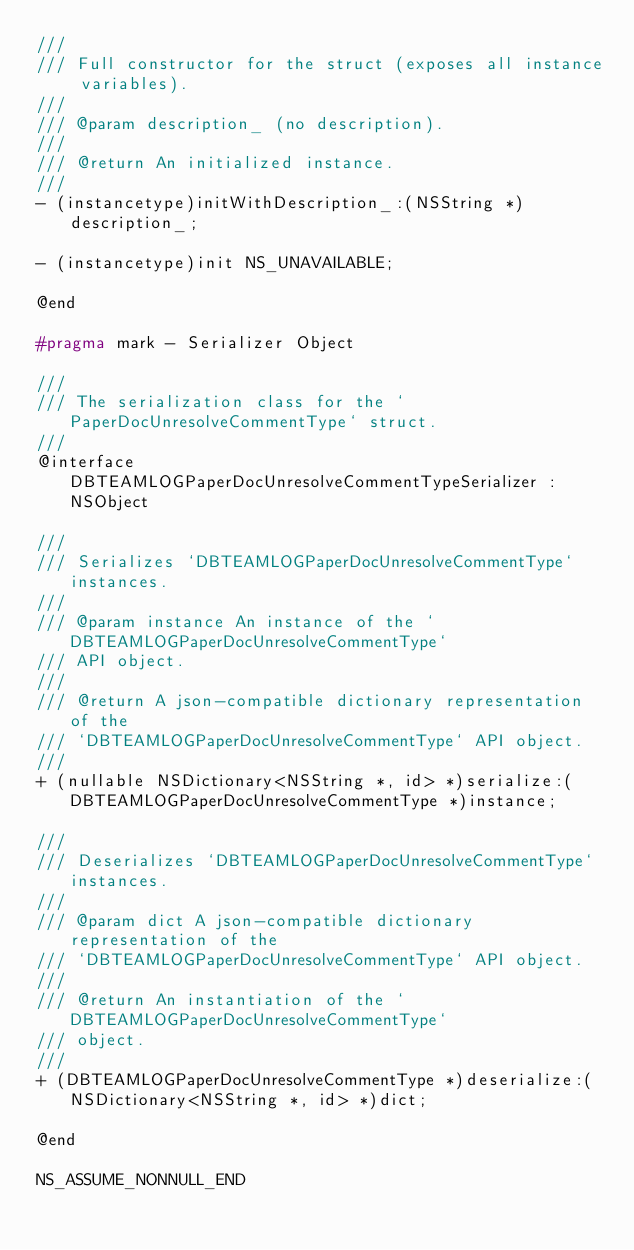Convert code to text. <code><loc_0><loc_0><loc_500><loc_500><_C_>///
/// Full constructor for the struct (exposes all instance variables).
///
/// @param description_ (no description).
///
/// @return An initialized instance.
///
- (instancetype)initWithDescription_:(NSString *)description_;

- (instancetype)init NS_UNAVAILABLE;

@end

#pragma mark - Serializer Object

///
/// The serialization class for the `PaperDocUnresolveCommentType` struct.
///
@interface DBTEAMLOGPaperDocUnresolveCommentTypeSerializer : NSObject

///
/// Serializes `DBTEAMLOGPaperDocUnresolveCommentType` instances.
///
/// @param instance An instance of the `DBTEAMLOGPaperDocUnresolveCommentType`
/// API object.
///
/// @return A json-compatible dictionary representation of the
/// `DBTEAMLOGPaperDocUnresolveCommentType` API object.
///
+ (nullable NSDictionary<NSString *, id> *)serialize:(DBTEAMLOGPaperDocUnresolveCommentType *)instance;

///
/// Deserializes `DBTEAMLOGPaperDocUnresolveCommentType` instances.
///
/// @param dict A json-compatible dictionary representation of the
/// `DBTEAMLOGPaperDocUnresolveCommentType` API object.
///
/// @return An instantiation of the `DBTEAMLOGPaperDocUnresolveCommentType`
/// object.
///
+ (DBTEAMLOGPaperDocUnresolveCommentType *)deserialize:(NSDictionary<NSString *, id> *)dict;

@end

NS_ASSUME_NONNULL_END
</code> 